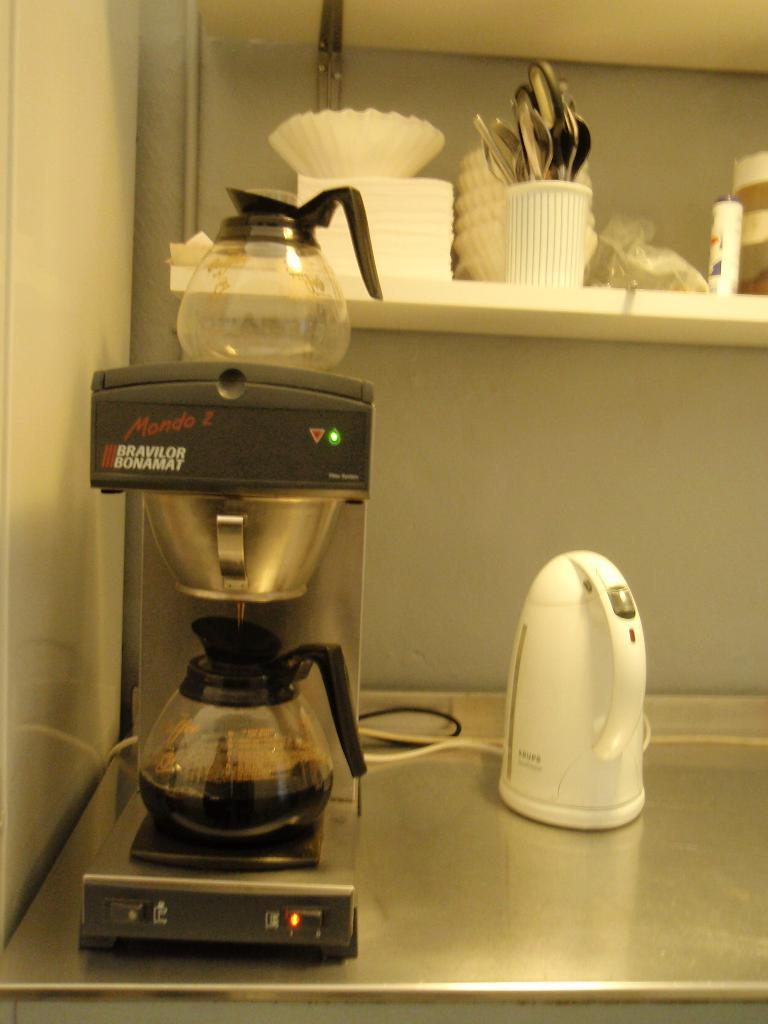<image>
Give a short and clear explanation of the subsequent image. A mondo 2 coffee maker on a stainless steel shelf. 